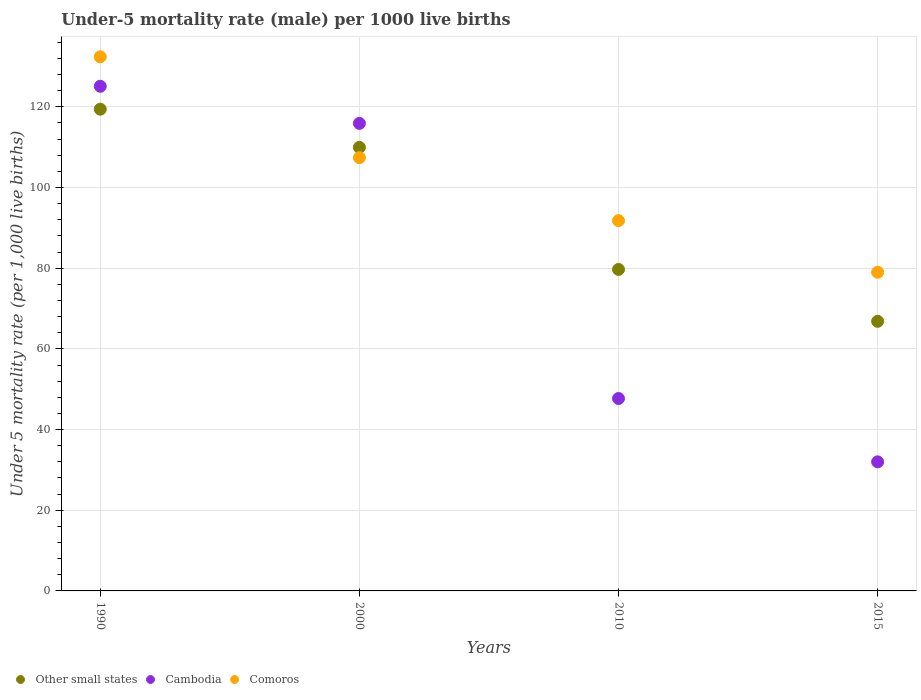How many different coloured dotlines are there?
Your answer should be very brief. 3. What is the under-five mortality rate in Cambodia in 1990?
Offer a very short reply. 125.1. Across all years, what is the maximum under-five mortality rate in Cambodia?
Your answer should be very brief. 125.1. Across all years, what is the minimum under-five mortality rate in Other small states?
Provide a succinct answer. 66.83. In which year was the under-five mortality rate in Cambodia minimum?
Keep it short and to the point. 2015. What is the total under-five mortality rate in Other small states in the graph?
Your answer should be compact. 375.9. What is the difference between the under-five mortality rate in Other small states in 2000 and that in 2010?
Offer a very short reply. 30.26. What is the difference between the under-five mortality rate in Comoros in 2015 and the under-five mortality rate in Other small states in 2010?
Your answer should be very brief. -0.69. What is the average under-five mortality rate in Comoros per year?
Provide a succinct answer. 102.65. In the year 2010, what is the difference between the under-five mortality rate in Comoros and under-five mortality rate in Other small states?
Your response must be concise. 12.11. What is the ratio of the under-five mortality rate in Comoros in 1990 to that in 2015?
Offer a terse response. 1.68. What is the difference between the highest and the second highest under-five mortality rate in Other small states?
Keep it short and to the point. 9.47. What is the difference between the highest and the lowest under-five mortality rate in Comoros?
Your answer should be very brief. 53.4. Is it the case that in every year, the sum of the under-five mortality rate in Other small states and under-five mortality rate in Comoros  is greater than the under-five mortality rate in Cambodia?
Make the answer very short. Yes. Does the under-five mortality rate in Comoros monotonically increase over the years?
Offer a terse response. No. How many dotlines are there?
Your answer should be very brief. 3. Where does the legend appear in the graph?
Give a very brief answer. Bottom left. How many legend labels are there?
Keep it short and to the point. 3. What is the title of the graph?
Ensure brevity in your answer.  Under-5 mortality rate (male) per 1000 live births. Does "Sint Maarten (Dutch part)" appear as one of the legend labels in the graph?
Make the answer very short. No. What is the label or title of the Y-axis?
Provide a succinct answer. Under 5 mortality rate (per 1,0 live births). What is the Under 5 mortality rate (per 1,000 live births) of Other small states in 1990?
Offer a terse response. 119.42. What is the Under 5 mortality rate (per 1,000 live births) of Cambodia in 1990?
Make the answer very short. 125.1. What is the Under 5 mortality rate (per 1,000 live births) in Comoros in 1990?
Keep it short and to the point. 132.4. What is the Under 5 mortality rate (per 1,000 live births) of Other small states in 2000?
Give a very brief answer. 109.95. What is the Under 5 mortality rate (per 1,000 live births) in Cambodia in 2000?
Your response must be concise. 115.9. What is the Under 5 mortality rate (per 1,000 live births) of Comoros in 2000?
Provide a short and direct response. 107.4. What is the Under 5 mortality rate (per 1,000 live births) of Other small states in 2010?
Provide a succinct answer. 79.69. What is the Under 5 mortality rate (per 1,000 live births) of Cambodia in 2010?
Your answer should be compact. 47.7. What is the Under 5 mortality rate (per 1,000 live births) in Comoros in 2010?
Give a very brief answer. 91.8. What is the Under 5 mortality rate (per 1,000 live births) of Other small states in 2015?
Offer a very short reply. 66.83. What is the Under 5 mortality rate (per 1,000 live births) of Cambodia in 2015?
Your answer should be very brief. 32. What is the Under 5 mortality rate (per 1,000 live births) in Comoros in 2015?
Your answer should be compact. 79. Across all years, what is the maximum Under 5 mortality rate (per 1,000 live births) of Other small states?
Offer a terse response. 119.42. Across all years, what is the maximum Under 5 mortality rate (per 1,000 live births) in Cambodia?
Your response must be concise. 125.1. Across all years, what is the maximum Under 5 mortality rate (per 1,000 live births) of Comoros?
Keep it short and to the point. 132.4. Across all years, what is the minimum Under 5 mortality rate (per 1,000 live births) in Other small states?
Provide a short and direct response. 66.83. Across all years, what is the minimum Under 5 mortality rate (per 1,000 live births) in Comoros?
Your response must be concise. 79. What is the total Under 5 mortality rate (per 1,000 live births) of Other small states in the graph?
Your answer should be very brief. 375.9. What is the total Under 5 mortality rate (per 1,000 live births) of Cambodia in the graph?
Your response must be concise. 320.7. What is the total Under 5 mortality rate (per 1,000 live births) in Comoros in the graph?
Give a very brief answer. 410.6. What is the difference between the Under 5 mortality rate (per 1,000 live births) of Other small states in 1990 and that in 2000?
Provide a succinct answer. 9.47. What is the difference between the Under 5 mortality rate (per 1,000 live births) of Other small states in 1990 and that in 2010?
Your response must be concise. 39.73. What is the difference between the Under 5 mortality rate (per 1,000 live births) in Cambodia in 1990 and that in 2010?
Your answer should be compact. 77.4. What is the difference between the Under 5 mortality rate (per 1,000 live births) of Comoros in 1990 and that in 2010?
Provide a succinct answer. 40.6. What is the difference between the Under 5 mortality rate (per 1,000 live births) of Other small states in 1990 and that in 2015?
Make the answer very short. 52.59. What is the difference between the Under 5 mortality rate (per 1,000 live births) in Cambodia in 1990 and that in 2015?
Give a very brief answer. 93.1. What is the difference between the Under 5 mortality rate (per 1,000 live births) of Comoros in 1990 and that in 2015?
Ensure brevity in your answer.  53.4. What is the difference between the Under 5 mortality rate (per 1,000 live births) of Other small states in 2000 and that in 2010?
Offer a terse response. 30.26. What is the difference between the Under 5 mortality rate (per 1,000 live births) in Cambodia in 2000 and that in 2010?
Your answer should be very brief. 68.2. What is the difference between the Under 5 mortality rate (per 1,000 live births) in Other small states in 2000 and that in 2015?
Make the answer very short. 43.12. What is the difference between the Under 5 mortality rate (per 1,000 live births) of Cambodia in 2000 and that in 2015?
Provide a short and direct response. 83.9. What is the difference between the Under 5 mortality rate (per 1,000 live births) of Comoros in 2000 and that in 2015?
Offer a very short reply. 28.4. What is the difference between the Under 5 mortality rate (per 1,000 live births) of Other small states in 2010 and that in 2015?
Ensure brevity in your answer.  12.86. What is the difference between the Under 5 mortality rate (per 1,000 live births) of Comoros in 2010 and that in 2015?
Ensure brevity in your answer.  12.8. What is the difference between the Under 5 mortality rate (per 1,000 live births) in Other small states in 1990 and the Under 5 mortality rate (per 1,000 live births) in Cambodia in 2000?
Offer a terse response. 3.52. What is the difference between the Under 5 mortality rate (per 1,000 live births) in Other small states in 1990 and the Under 5 mortality rate (per 1,000 live births) in Comoros in 2000?
Provide a succinct answer. 12.02. What is the difference between the Under 5 mortality rate (per 1,000 live births) of Other small states in 1990 and the Under 5 mortality rate (per 1,000 live births) of Cambodia in 2010?
Offer a very short reply. 71.72. What is the difference between the Under 5 mortality rate (per 1,000 live births) in Other small states in 1990 and the Under 5 mortality rate (per 1,000 live births) in Comoros in 2010?
Your answer should be very brief. 27.62. What is the difference between the Under 5 mortality rate (per 1,000 live births) in Cambodia in 1990 and the Under 5 mortality rate (per 1,000 live births) in Comoros in 2010?
Offer a terse response. 33.3. What is the difference between the Under 5 mortality rate (per 1,000 live births) of Other small states in 1990 and the Under 5 mortality rate (per 1,000 live births) of Cambodia in 2015?
Make the answer very short. 87.42. What is the difference between the Under 5 mortality rate (per 1,000 live births) in Other small states in 1990 and the Under 5 mortality rate (per 1,000 live births) in Comoros in 2015?
Offer a very short reply. 40.42. What is the difference between the Under 5 mortality rate (per 1,000 live births) in Cambodia in 1990 and the Under 5 mortality rate (per 1,000 live births) in Comoros in 2015?
Ensure brevity in your answer.  46.1. What is the difference between the Under 5 mortality rate (per 1,000 live births) in Other small states in 2000 and the Under 5 mortality rate (per 1,000 live births) in Cambodia in 2010?
Your response must be concise. 62.25. What is the difference between the Under 5 mortality rate (per 1,000 live births) in Other small states in 2000 and the Under 5 mortality rate (per 1,000 live births) in Comoros in 2010?
Make the answer very short. 18.15. What is the difference between the Under 5 mortality rate (per 1,000 live births) of Cambodia in 2000 and the Under 5 mortality rate (per 1,000 live births) of Comoros in 2010?
Your answer should be compact. 24.1. What is the difference between the Under 5 mortality rate (per 1,000 live births) of Other small states in 2000 and the Under 5 mortality rate (per 1,000 live births) of Cambodia in 2015?
Your answer should be very brief. 77.95. What is the difference between the Under 5 mortality rate (per 1,000 live births) in Other small states in 2000 and the Under 5 mortality rate (per 1,000 live births) in Comoros in 2015?
Ensure brevity in your answer.  30.95. What is the difference between the Under 5 mortality rate (per 1,000 live births) of Cambodia in 2000 and the Under 5 mortality rate (per 1,000 live births) of Comoros in 2015?
Your answer should be very brief. 36.9. What is the difference between the Under 5 mortality rate (per 1,000 live births) in Other small states in 2010 and the Under 5 mortality rate (per 1,000 live births) in Cambodia in 2015?
Your answer should be compact. 47.69. What is the difference between the Under 5 mortality rate (per 1,000 live births) of Other small states in 2010 and the Under 5 mortality rate (per 1,000 live births) of Comoros in 2015?
Give a very brief answer. 0.69. What is the difference between the Under 5 mortality rate (per 1,000 live births) in Cambodia in 2010 and the Under 5 mortality rate (per 1,000 live births) in Comoros in 2015?
Give a very brief answer. -31.3. What is the average Under 5 mortality rate (per 1,000 live births) in Other small states per year?
Your answer should be very brief. 93.97. What is the average Under 5 mortality rate (per 1,000 live births) in Cambodia per year?
Keep it short and to the point. 80.17. What is the average Under 5 mortality rate (per 1,000 live births) in Comoros per year?
Your answer should be compact. 102.65. In the year 1990, what is the difference between the Under 5 mortality rate (per 1,000 live births) in Other small states and Under 5 mortality rate (per 1,000 live births) in Cambodia?
Give a very brief answer. -5.68. In the year 1990, what is the difference between the Under 5 mortality rate (per 1,000 live births) of Other small states and Under 5 mortality rate (per 1,000 live births) of Comoros?
Offer a very short reply. -12.98. In the year 2000, what is the difference between the Under 5 mortality rate (per 1,000 live births) in Other small states and Under 5 mortality rate (per 1,000 live births) in Cambodia?
Provide a succinct answer. -5.95. In the year 2000, what is the difference between the Under 5 mortality rate (per 1,000 live births) of Other small states and Under 5 mortality rate (per 1,000 live births) of Comoros?
Keep it short and to the point. 2.55. In the year 2010, what is the difference between the Under 5 mortality rate (per 1,000 live births) in Other small states and Under 5 mortality rate (per 1,000 live births) in Cambodia?
Make the answer very short. 31.99. In the year 2010, what is the difference between the Under 5 mortality rate (per 1,000 live births) of Other small states and Under 5 mortality rate (per 1,000 live births) of Comoros?
Provide a short and direct response. -12.11. In the year 2010, what is the difference between the Under 5 mortality rate (per 1,000 live births) in Cambodia and Under 5 mortality rate (per 1,000 live births) in Comoros?
Provide a short and direct response. -44.1. In the year 2015, what is the difference between the Under 5 mortality rate (per 1,000 live births) in Other small states and Under 5 mortality rate (per 1,000 live births) in Cambodia?
Your answer should be very brief. 34.83. In the year 2015, what is the difference between the Under 5 mortality rate (per 1,000 live births) of Other small states and Under 5 mortality rate (per 1,000 live births) of Comoros?
Your answer should be compact. -12.17. In the year 2015, what is the difference between the Under 5 mortality rate (per 1,000 live births) of Cambodia and Under 5 mortality rate (per 1,000 live births) of Comoros?
Offer a very short reply. -47. What is the ratio of the Under 5 mortality rate (per 1,000 live births) in Other small states in 1990 to that in 2000?
Your answer should be compact. 1.09. What is the ratio of the Under 5 mortality rate (per 1,000 live births) in Cambodia in 1990 to that in 2000?
Offer a very short reply. 1.08. What is the ratio of the Under 5 mortality rate (per 1,000 live births) of Comoros in 1990 to that in 2000?
Your answer should be compact. 1.23. What is the ratio of the Under 5 mortality rate (per 1,000 live births) in Other small states in 1990 to that in 2010?
Offer a very short reply. 1.5. What is the ratio of the Under 5 mortality rate (per 1,000 live births) of Cambodia in 1990 to that in 2010?
Offer a very short reply. 2.62. What is the ratio of the Under 5 mortality rate (per 1,000 live births) of Comoros in 1990 to that in 2010?
Your answer should be very brief. 1.44. What is the ratio of the Under 5 mortality rate (per 1,000 live births) of Other small states in 1990 to that in 2015?
Your answer should be compact. 1.79. What is the ratio of the Under 5 mortality rate (per 1,000 live births) of Cambodia in 1990 to that in 2015?
Offer a very short reply. 3.91. What is the ratio of the Under 5 mortality rate (per 1,000 live births) of Comoros in 1990 to that in 2015?
Give a very brief answer. 1.68. What is the ratio of the Under 5 mortality rate (per 1,000 live births) of Other small states in 2000 to that in 2010?
Your response must be concise. 1.38. What is the ratio of the Under 5 mortality rate (per 1,000 live births) of Cambodia in 2000 to that in 2010?
Keep it short and to the point. 2.43. What is the ratio of the Under 5 mortality rate (per 1,000 live births) of Comoros in 2000 to that in 2010?
Ensure brevity in your answer.  1.17. What is the ratio of the Under 5 mortality rate (per 1,000 live births) of Other small states in 2000 to that in 2015?
Offer a terse response. 1.65. What is the ratio of the Under 5 mortality rate (per 1,000 live births) in Cambodia in 2000 to that in 2015?
Give a very brief answer. 3.62. What is the ratio of the Under 5 mortality rate (per 1,000 live births) of Comoros in 2000 to that in 2015?
Offer a very short reply. 1.36. What is the ratio of the Under 5 mortality rate (per 1,000 live births) in Other small states in 2010 to that in 2015?
Offer a very short reply. 1.19. What is the ratio of the Under 5 mortality rate (per 1,000 live births) in Cambodia in 2010 to that in 2015?
Ensure brevity in your answer.  1.49. What is the ratio of the Under 5 mortality rate (per 1,000 live births) in Comoros in 2010 to that in 2015?
Keep it short and to the point. 1.16. What is the difference between the highest and the second highest Under 5 mortality rate (per 1,000 live births) of Other small states?
Provide a short and direct response. 9.47. What is the difference between the highest and the second highest Under 5 mortality rate (per 1,000 live births) of Comoros?
Provide a short and direct response. 25. What is the difference between the highest and the lowest Under 5 mortality rate (per 1,000 live births) in Other small states?
Give a very brief answer. 52.59. What is the difference between the highest and the lowest Under 5 mortality rate (per 1,000 live births) in Cambodia?
Make the answer very short. 93.1. What is the difference between the highest and the lowest Under 5 mortality rate (per 1,000 live births) in Comoros?
Your response must be concise. 53.4. 